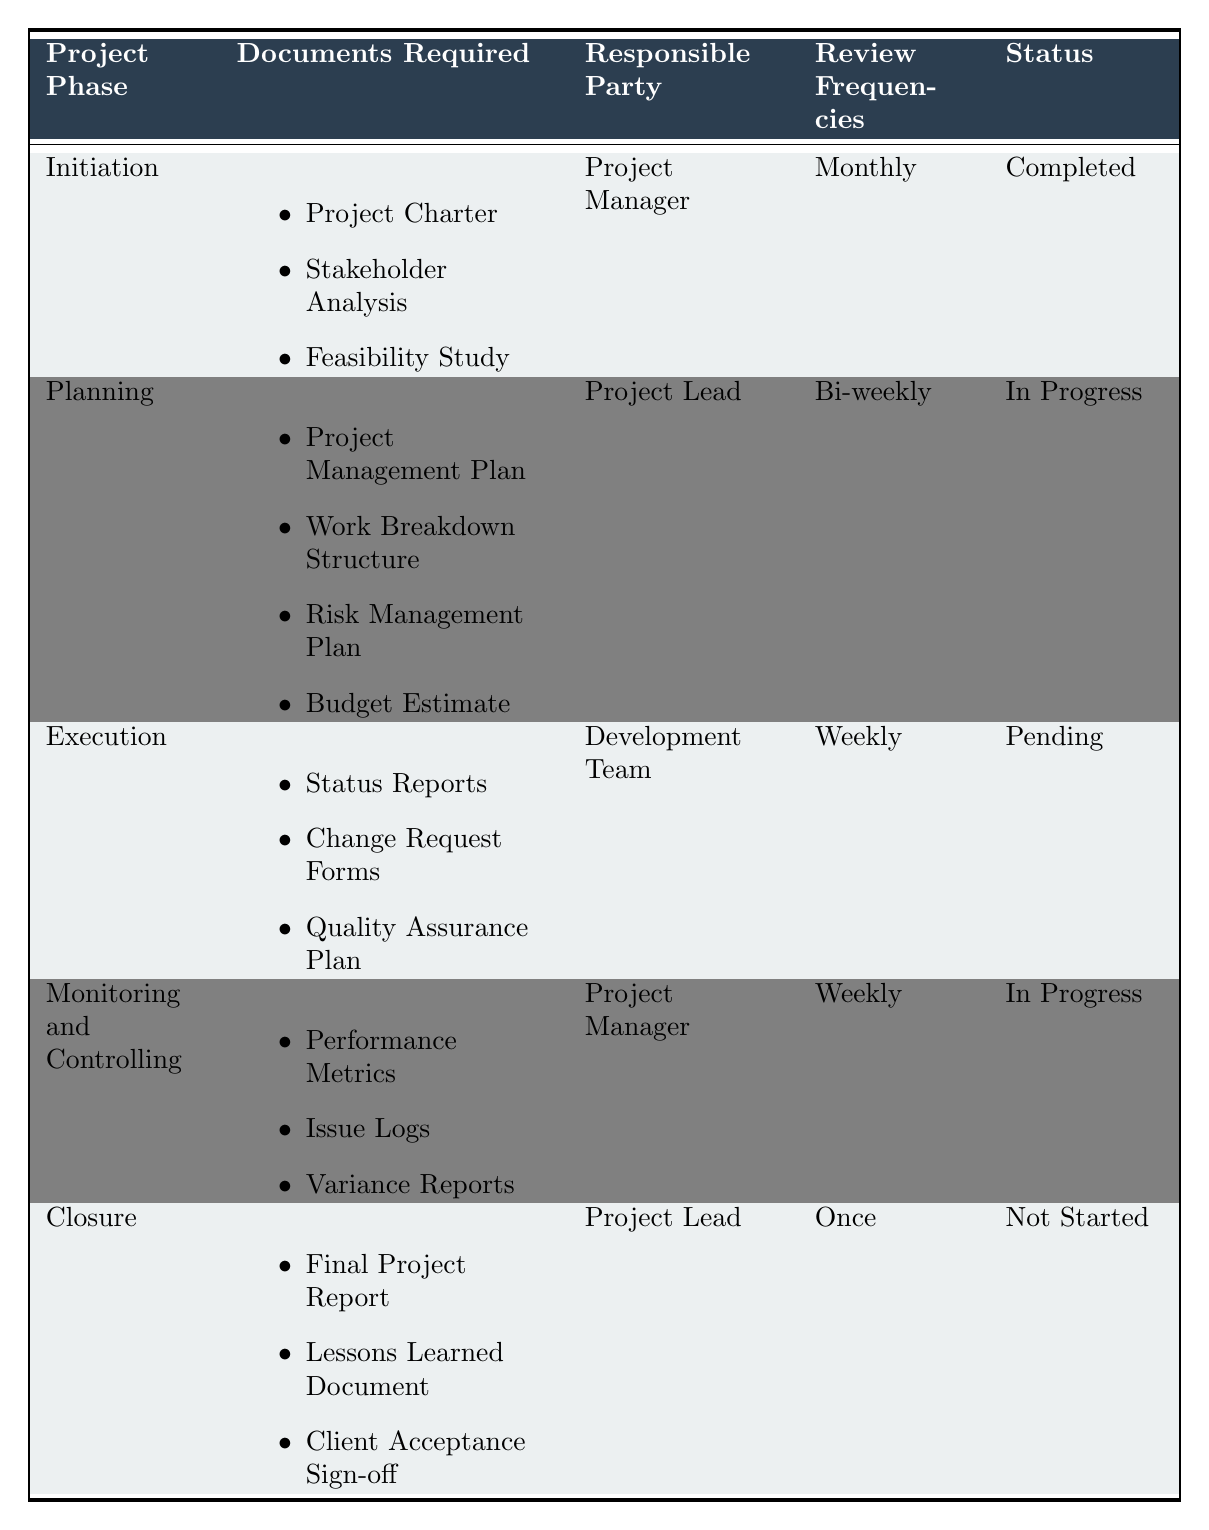What documents are required for the Planning phase? The Planning phase requires a Project Management Plan, Work Breakdown Structure, Risk Management Plan, and Budget Estimate, which can be found in the "Documents Required" column under the Planning phase.
Answer: Project Management Plan, Work Breakdown Structure, Risk Management Plan, Budget Estimate Who is responsible for the Monitoring and Controlling phase? The responsible party for the Monitoring and Controlling phase is listed as the Project Manager in the "Responsible Party" column.
Answer: Project Manager What is the review frequency for the Execution phase? The Execution phase's review frequency is noted as Weekly in the "Review Frequencies" column.
Answer: Weekly Is the status of the Closure phase completed? The status of the Closure phase is listed as Not Started, so it is not completed.
Answer: No How many documents are required for the Initiation phase? The Initiation phase requires three documents, which can be counted by looking at the "Documents Required" section for that phase.
Answer: 3 Which project phase has a status of In Progress? The Planning and Monitoring and Controlling phases both have a status of In Progress, identified by looking at the "Status" column.
Answer: Planning, Monitoring and Controlling What is the difference in review frequency between the Closure and Initiation phases? The Closure phase has a review frequency of Once, while the Initiation phase has a Monthly frequency. The difference in frequencies is calculated as (1 month - 1 time) which does not yield a numeric difference in this context because they are not directly comparable. Thus, they are fundamentally different.
Answer: Different Which project phase has the lowest status completion level? The Closure phase has the lowest status completion level, as it is marked as Not Started, compared to the others.
Answer: Closure If the Planning phase is completed, how many documents need to be ready for the next phases? The Planning phase is currently In Progress. However, if it were completed, documents for the next phase (Execution) would include three documents, indicating the need for these documents for readiness in the next phase.
Answer: 3 Are there more documents required for Execution than for Closure? The Execution phase requires three documents, while the Closure phase requires three documents as well, indicating they are equal in terms of document count.
Answer: No 